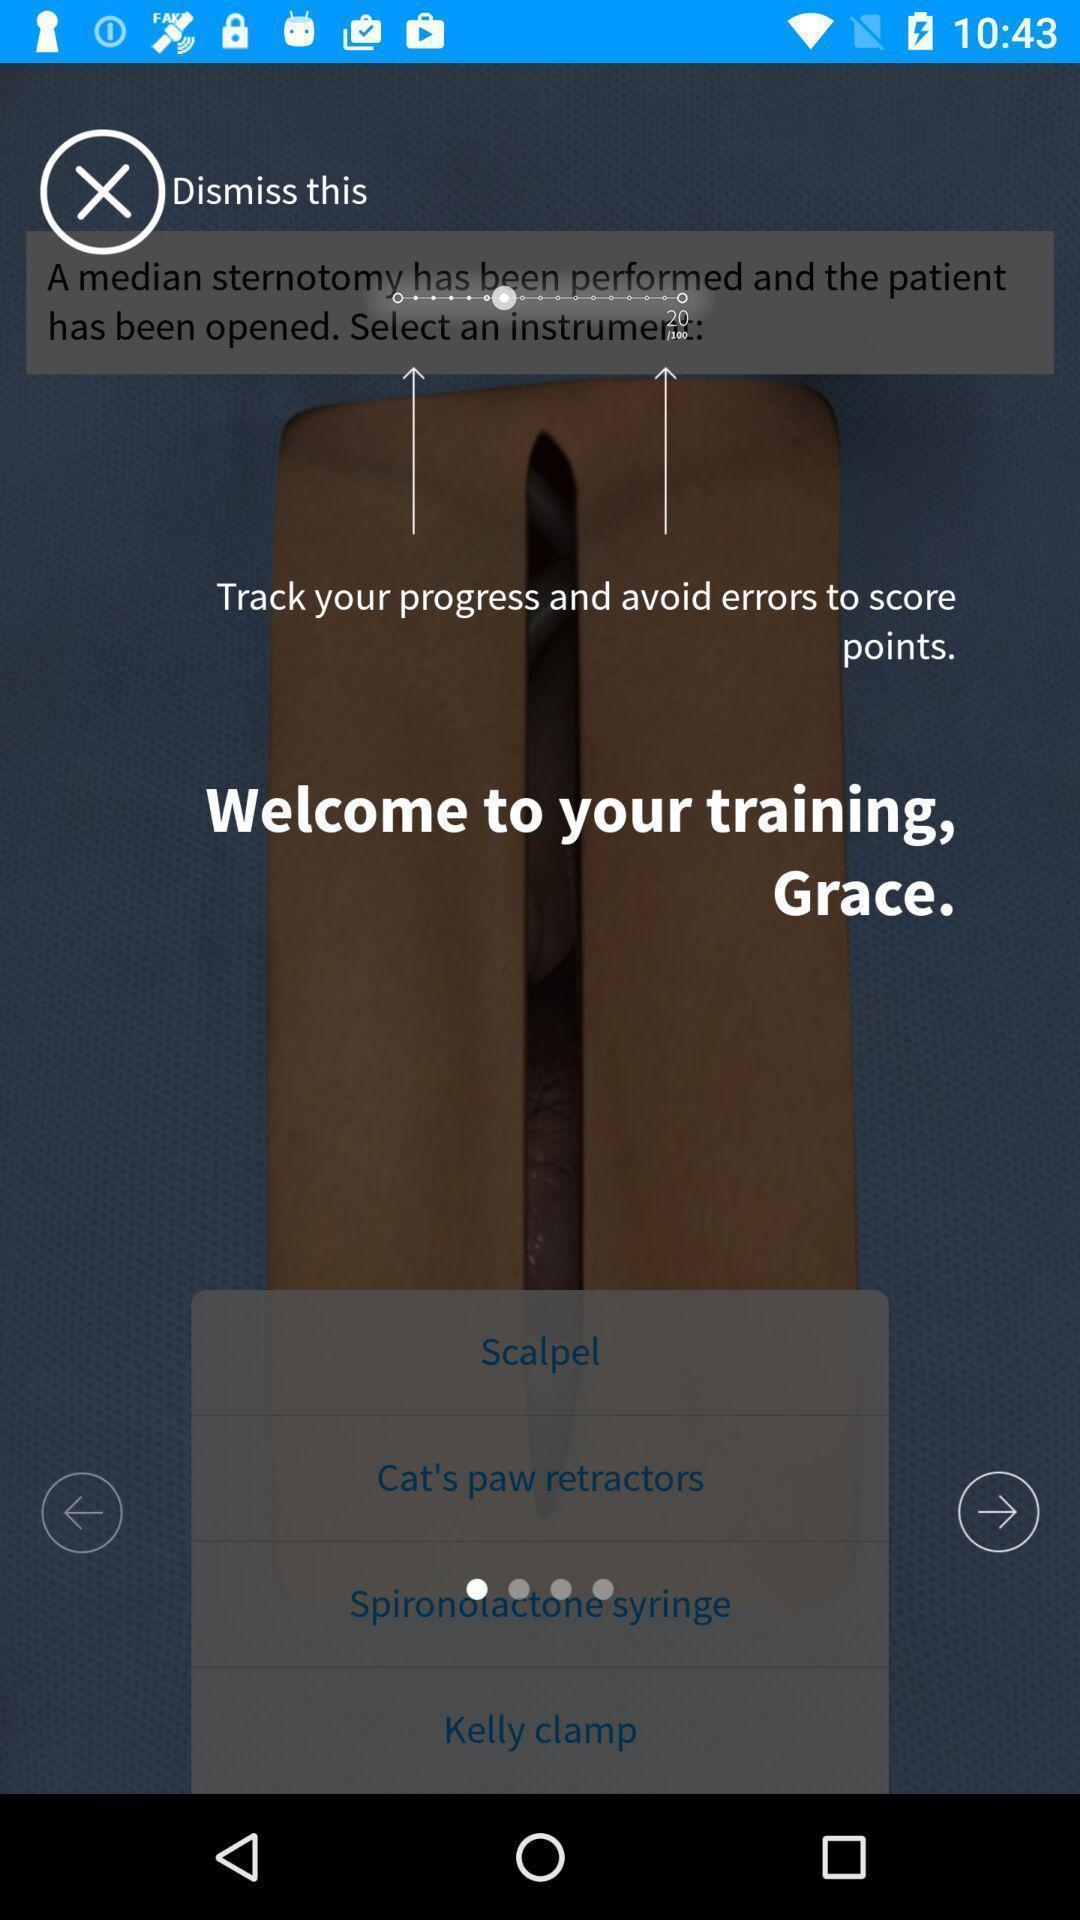Describe the key features of this screenshot. Welcome page of a surgical training platform. 